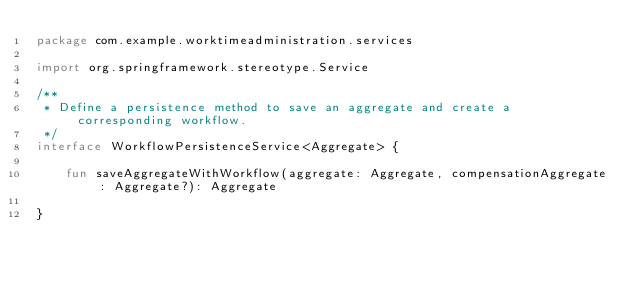Convert code to text. <code><loc_0><loc_0><loc_500><loc_500><_Kotlin_>package com.example.worktimeadministration.services

import org.springframework.stereotype.Service

/**
 * Define a persistence method to save an aggregate and create a corresponding workflow.
 */
interface WorkflowPersistenceService<Aggregate> {

    fun saveAggregateWithWorkflow(aggregate: Aggregate, compensationAggregate: Aggregate?): Aggregate

}</code> 